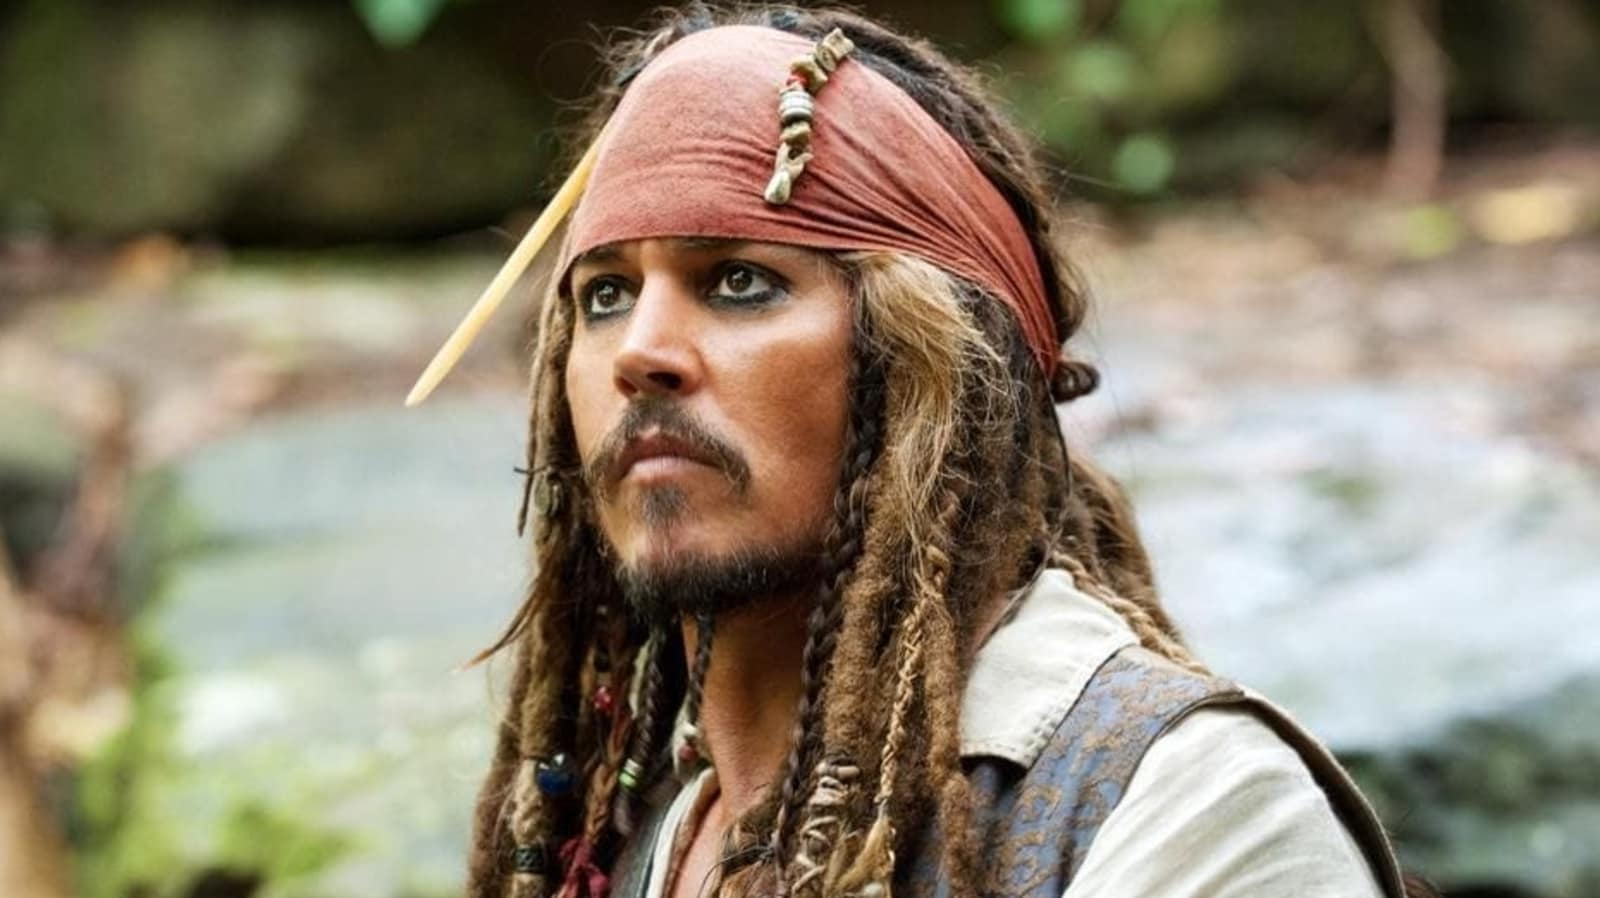Can you describe the emotions conveyed by the character in this image? The character in the image seems to be deep in thought, with a contemplative and serious expression. His gaze is directed slightly off to the side, suggesting he might be pondering an important decision or anticipating an upcoming event. The serious demeanor could hint at a mix of concern or readiness for an unexpected adventure. What do you think the character might be thinking about? Given the character's iconic role as Captain Jack Sparrow, he might be contemplating his next move or strategy to navigate troublesome waters, evade an enemy, or uncover hidden treasure. The setting around him is serene, which could also suggest a moment of reflection amidst the chaos that usually surrounds his adventures. Imagine a scenario where the character is on a quest to find a mythical artifact. What challenges might he face? If Captain Jack Sparrow were on a quest to find a mythical artifact, he would likely encounter a series of challenges including difficult terrain, treacherous waters, and rival pirates also seeking the sharegpt4v/same artifact. He might face puzzles and traps designed to protect the artifact, mystical creatures guarding the site, and perhaps even internal dilemmas about the moral implications of acquiring such an object. His wit, bravery, and resourcefulness would be put to the test at every turn. 